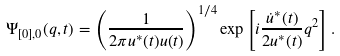<formula> <loc_0><loc_0><loc_500><loc_500>\Psi _ { [ 0 ] , 0 } ( q , t ) = \left ( \frac { 1 } { 2 \pi u ^ { * } ( t ) u ( t ) } \right ) ^ { 1 / 4 } \exp \left [ i \frac { \dot { u } ^ { * } ( t ) } { 2 u ^ { * } ( t ) } q ^ { 2 } \right ] .</formula> 